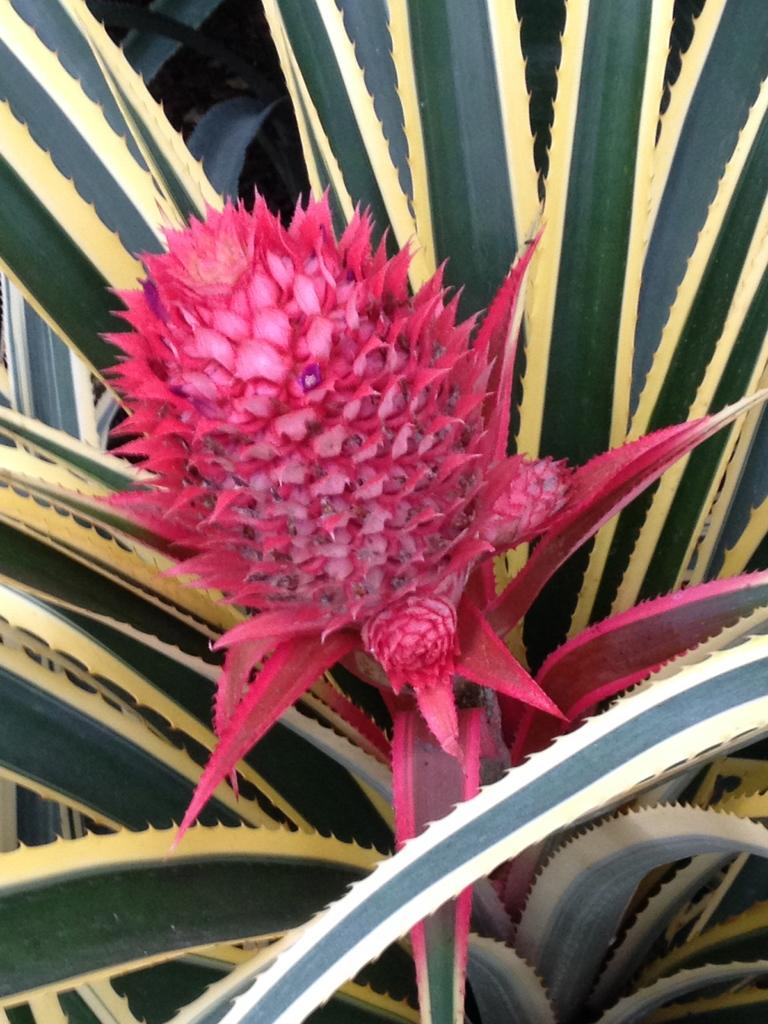What type of living organism can be seen in the image? There is a flower in the image. Are there any other plants visible in the image? Yes, there are plants in the image. What type of umbrella is being used to protect the plants from the wilderness in the image? There is no umbrella or reference to wilderness in the image; it only features a flower and other plants. 